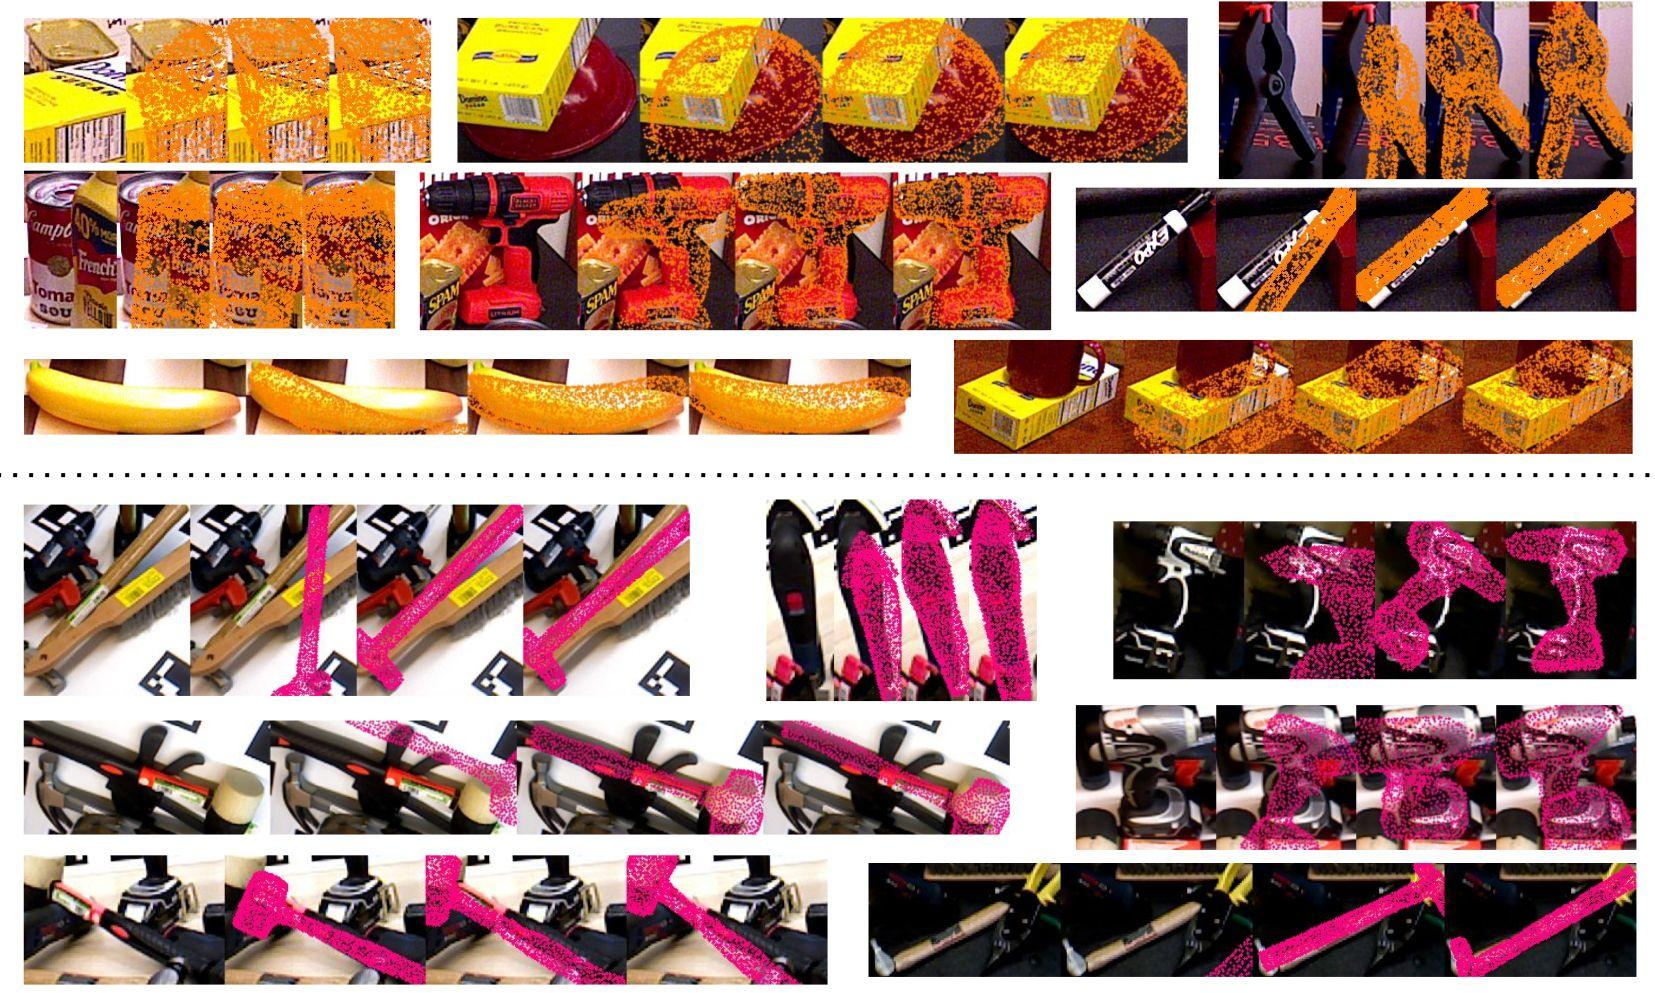How might these different patterns of corruption affect the utility of the images? The varying degrees of corruption displayed in these images directly impact their utility. In scenarios where these images are used for product recognition or inventory management, the corruption could prevent automatic systems from accurately identifying or counting items. It could also detract from a customer's online shopping experience by obscuring product details. Analyzing and addressing these patterns is critical in fields that rely on accurate visual information, such as digital imaging, computer vision, and data recovery processes. 